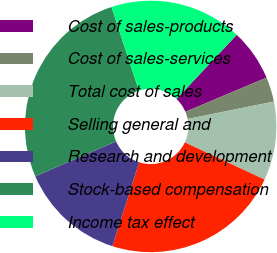Convert chart. <chart><loc_0><loc_0><loc_500><loc_500><pie_chart><fcel>Cost of sales-products<fcel>Cost of sales-services<fcel>Total cost of sales<fcel>Selling general and<fcel>Research and development<fcel>Stock-based compensation<fcel>Income tax effect<nl><fcel>6.65%<fcel>3.18%<fcel>10.12%<fcel>22.98%<fcel>13.58%<fcel>26.45%<fcel>17.05%<nl></chart> 